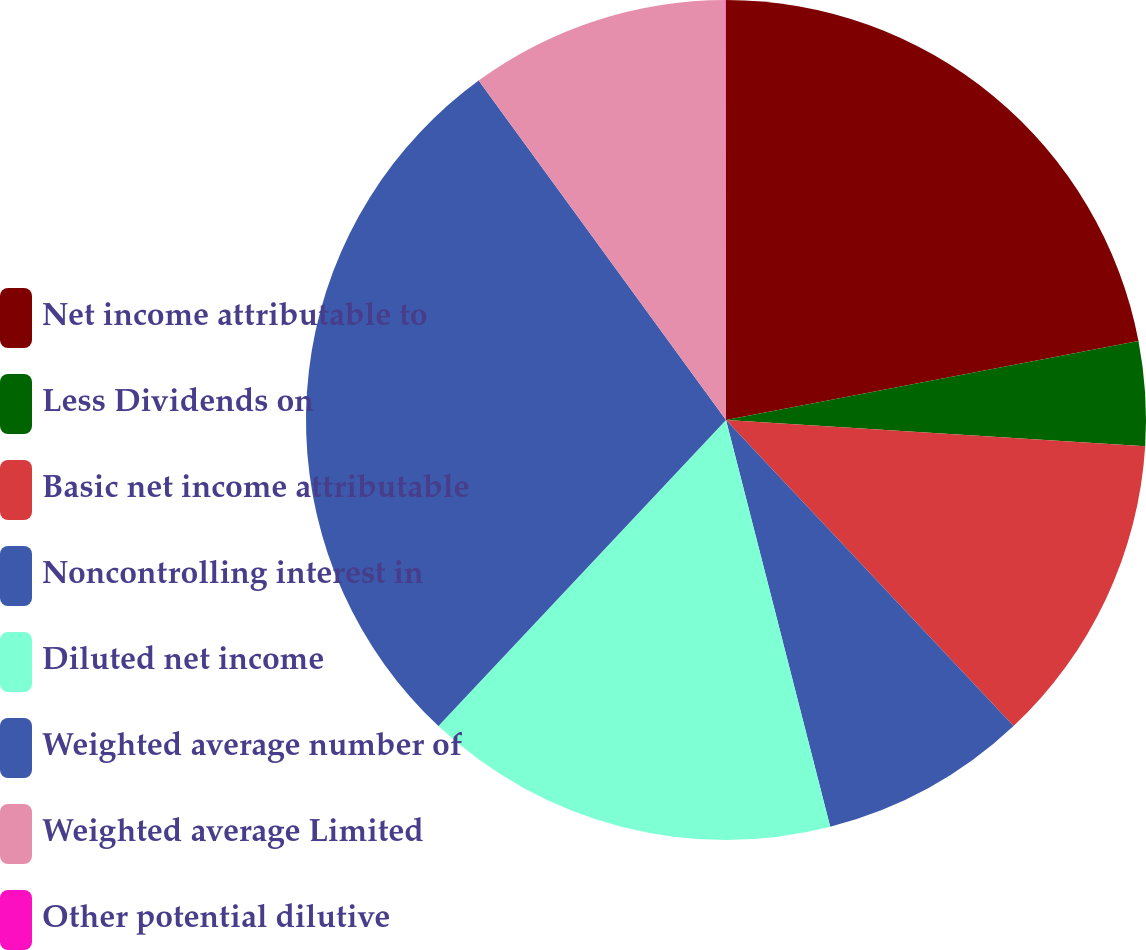Convert chart. <chart><loc_0><loc_0><loc_500><loc_500><pie_chart><fcel>Net income attributable to<fcel>Less Dividends on<fcel>Basic net income attributable<fcel>Noncontrolling interest in<fcel>Diluted net income<fcel>Weighted average number of<fcel>Weighted average Limited<fcel>Other potential dilutive<nl><fcel>21.98%<fcel>4.01%<fcel>12.0%<fcel>8.01%<fcel>15.99%<fcel>27.97%<fcel>10.0%<fcel>0.02%<nl></chart> 